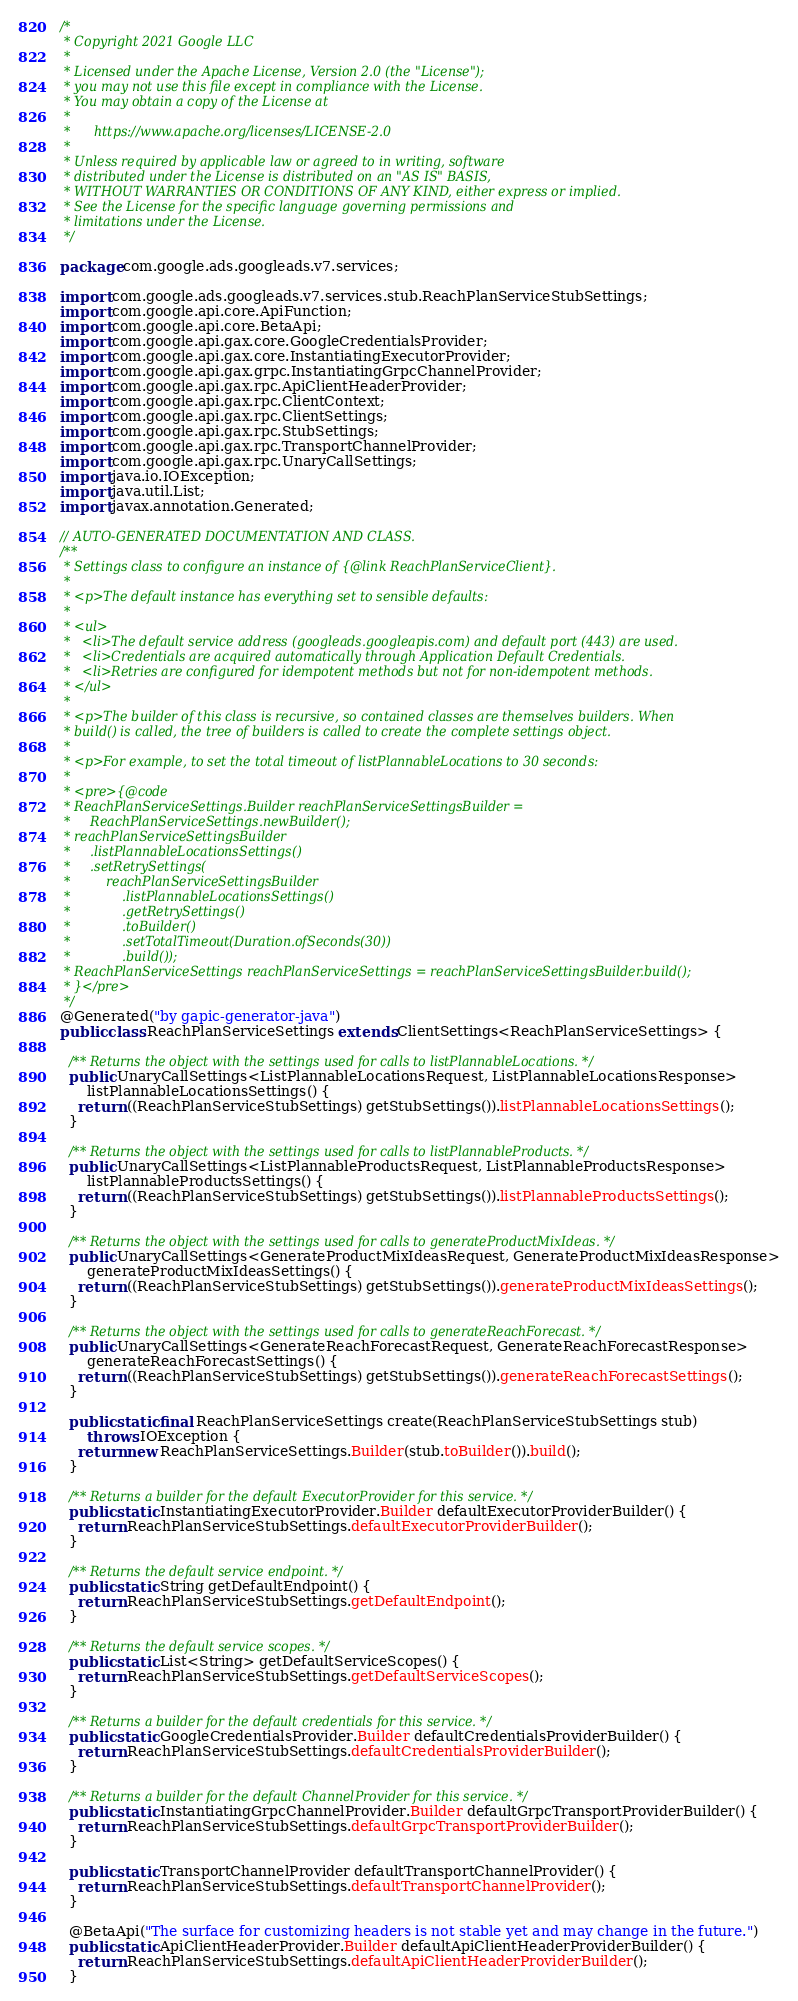<code> <loc_0><loc_0><loc_500><loc_500><_Java_>/*
 * Copyright 2021 Google LLC
 *
 * Licensed under the Apache License, Version 2.0 (the "License");
 * you may not use this file except in compliance with the License.
 * You may obtain a copy of the License at
 *
 *      https://www.apache.org/licenses/LICENSE-2.0
 *
 * Unless required by applicable law or agreed to in writing, software
 * distributed under the License is distributed on an "AS IS" BASIS,
 * WITHOUT WARRANTIES OR CONDITIONS OF ANY KIND, either express or implied.
 * See the License for the specific language governing permissions and
 * limitations under the License.
 */

package com.google.ads.googleads.v7.services;

import com.google.ads.googleads.v7.services.stub.ReachPlanServiceStubSettings;
import com.google.api.core.ApiFunction;
import com.google.api.core.BetaApi;
import com.google.api.gax.core.GoogleCredentialsProvider;
import com.google.api.gax.core.InstantiatingExecutorProvider;
import com.google.api.gax.grpc.InstantiatingGrpcChannelProvider;
import com.google.api.gax.rpc.ApiClientHeaderProvider;
import com.google.api.gax.rpc.ClientContext;
import com.google.api.gax.rpc.ClientSettings;
import com.google.api.gax.rpc.StubSettings;
import com.google.api.gax.rpc.TransportChannelProvider;
import com.google.api.gax.rpc.UnaryCallSettings;
import java.io.IOException;
import java.util.List;
import javax.annotation.Generated;

// AUTO-GENERATED DOCUMENTATION AND CLASS.
/**
 * Settings class to configure an instance of {@link ReachPlanServiceClient}.
 *
 * <p>The default instance has everything set to sensible defaults:
 *
 * <ul>
 *   <li>The default service address (googleads.googleapis.com) and default port (443) are used.
 *   <li>Credentials are acquired automatically through Application Default Credentials.
 *   <li>Retries are configured for idempotent methods but not for non-idempotent methods.
 * </ul>
 *
 * <p>The builder of this class is recursive, so contained classes are themselves builders. When
 * build() is called, the tree of builders is called to create the complete settings object.
 *
 * <p>For example, to set the total timeout of listPlannableLocations to 30 seconds:
 *
 * <pre>{@code
 * ReachPlanServiceSettings.Builder reachPlanServiceSettingsBuilder =
 *     ReachPlanServiceSettings.newBuilder();
 * reachPlanServiceSettingsBuilder
 *     .listPlannableLocationsSettings()
 *     .setRetrySettings(
 *         reachPlanServiceSettingsBuilder
 *             .listPlannableLocationsSettings()
 *             .getRetrySettings()
 *             .toBuilder()
 *             .setTotalTimeout(Duration.ofSeconds(30))
 *             .build());
 * ReachPlanServiceSettings reachPlanServiceSettings = reachPlanServiceSettingsBuilder.build();
 * }</pre>
 */
@Generated("by gapic-generator-java")
public class ReachPlanServiceSettings extends ClientSettings<ReachPlanServiceSettings> {

  /** Returns the object with the settings used for calls to listPlannableLocations. */
  public UnaryCallSettings<ListPlannableLocationsRequest, ListPlannableLocationsResponse>
      listPlannableLocationsSettings() {
    return ((ReachPlanServiceStubSettings) getStubSettings()).listPlannableLocationsSettings();
  }

  /** Returns the object with the settings used for calls to listPlannableProducts. */
  public UnaryCallSettings<ListPlannableProductsRequest, ListPlannableProductsResponse>
      listPlannableProductsSettings() {
    return ((ReachPlanServiceStubSettings) getStubSettings()).listPlannableProductsSettings();
  }

  /** Returns the object with the settings used for calls to generateProductMixIdeas. */
  public UnaryCallSettings<GenerateProductMixIdeasRequest, GenerateProductMixIdeasResponse>
      generateProductMixIdeasSettings() {
    return ((ReachPlanServiceStubSettings) getStubSettings()).generateProductMixIdeasSettings();
  }

  /** Returns the object with the settings used for calls to generateReachForecast. */
  public UnaryCallSettings<GenerateReachForecastRequest, GenerateReachForecastResponse>
      generateReachForecastSettings() {
    return ((ReachPlanServiceStubSettings) getStubSettings()).generateReachForecastSettings();
  }

  public static final ReachPlanServiceSettings create(ReachPlanServiceStubSettings stub)
      throws IOException {
    return new ReachPlanServiceSettings.Builder(stub.toBuilder()).build();
  }

  /** Returns a builder for the default ExecutorProvider for this service. */
  public static InstantiatingExecutorProvider.Builder defaultExecutorProviderBuilder() {
    return ReachPlanServiceStubSettings.defaultExecutorProviderBuilder();
  }

  /** Returns the default service endpoint. */
  public static String getDefaultEndpoint() {
    return ReachPlanServiceStubSettings.getDefaultEndpoint();
  }

  /** Returns the default service scopes. */
  public static List<String> getDefaultServiceScopes() {
    return ReachPlanServiceStubSettings.getDefaultServiceScopes();
  }

  /** Returns a builder for the default credentials for this service. */
  public static GoogleCredentialsProvider.Builder defaultCredentialsProviderBuilder() {
    return ReachPlanServiceStubSettings.defaultCredentialsProviderBuilder();
  }

  /** Returns a builder for the default ChannelProvider for this service. */
  public static InstantiatingGrpcChannelProvider.Builder defaultGrpcTransportProviderBuilder() {
    return ReachPlanServiceStubSettings.defaultGrpcTransportProviderBuilder();
  }

  public static TransportChannelProvider defaultTransportChannelProvider() {
    return ReachPlanServiceStubSettings.defaultTransportChannelProvider();
  }

  @BetaApi("The surface for customizing headers is not stable yet and may change in the future.")
  public static ApiClientHeaderProvider.Builder defaultApiClientHeaderProviderBuilder() {
    return ReachPlanServiceStubSettings.defaultApiClientHeaderProviderBuilder();
  }
</code> 